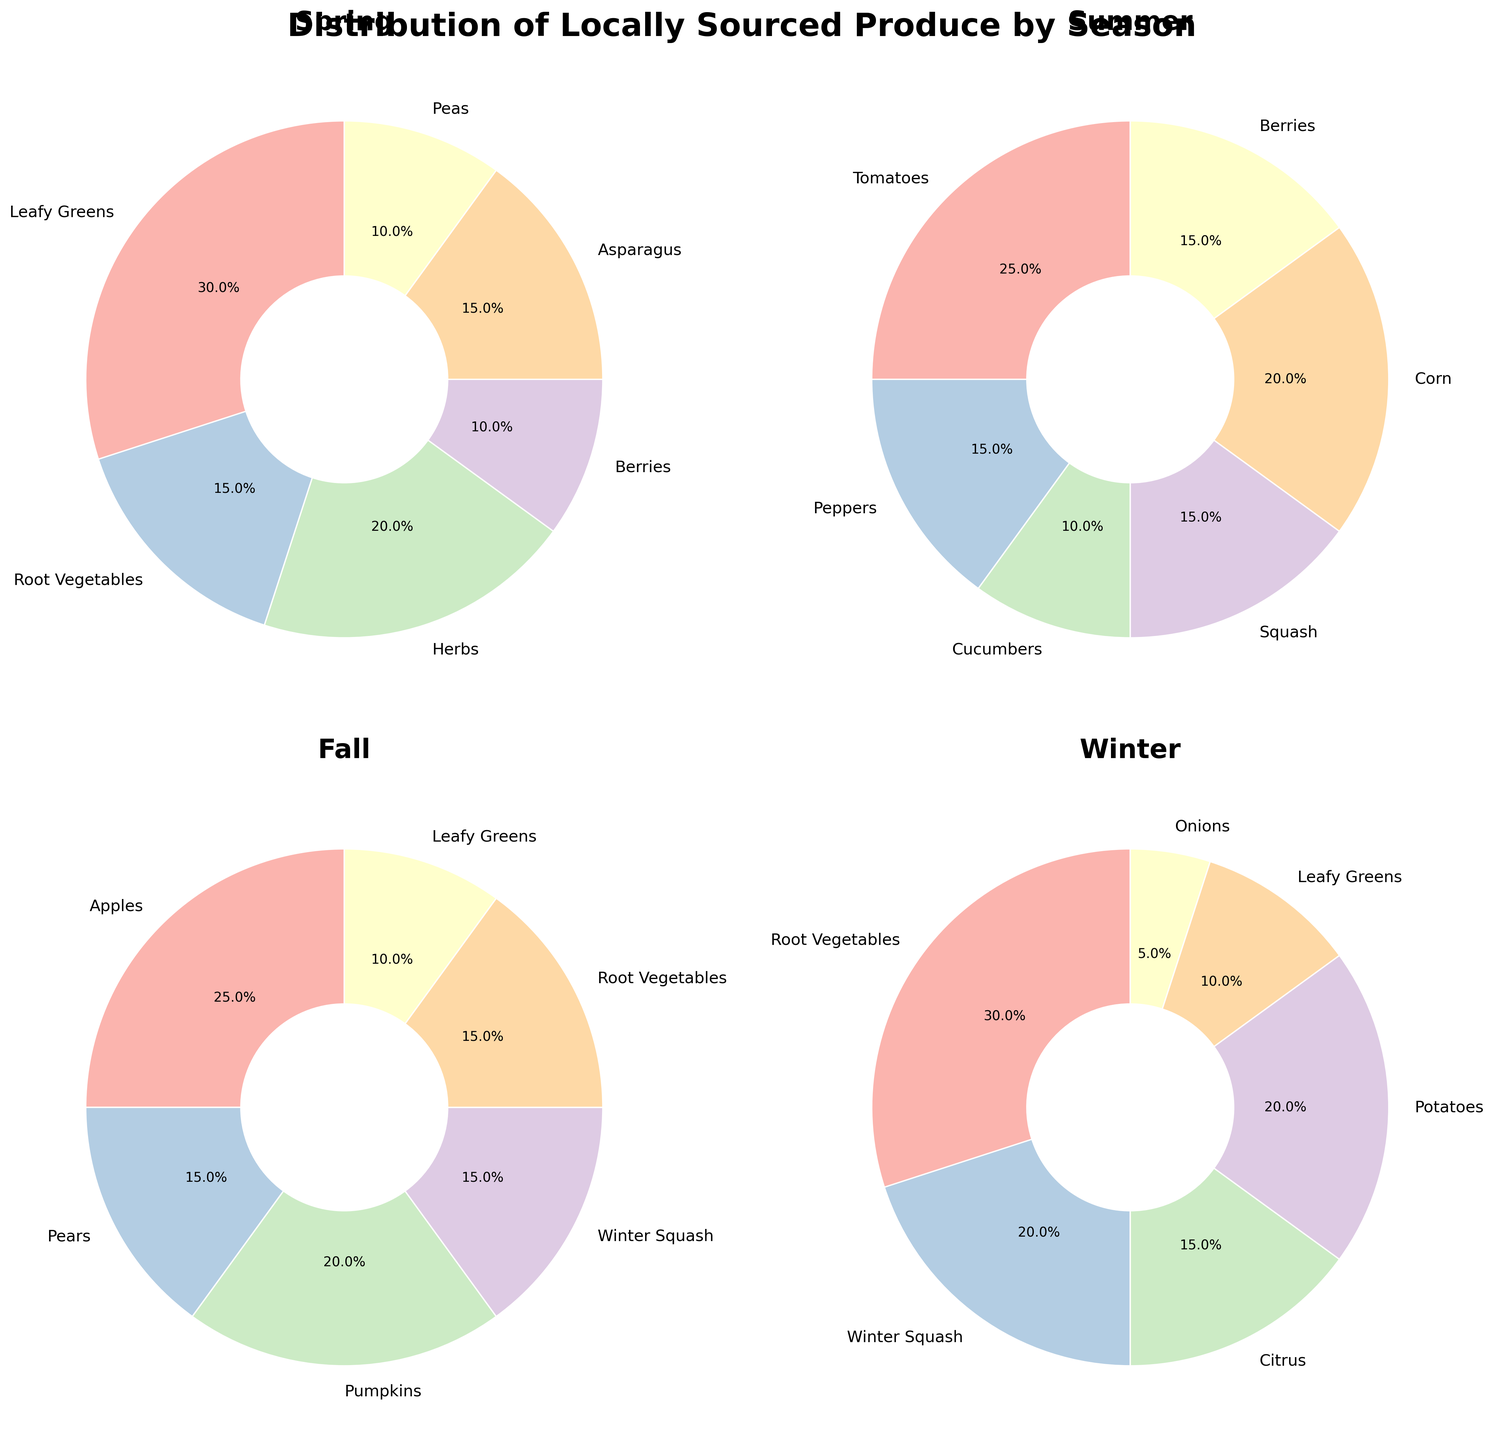What percentage of produce in Winter is composed of Root Vegetables and Potatoes combined? First, locate the percentages of Root Vegetables (30%) and Potatoes (20%) in Winter. Then, add these percentages together: 30% + 20% = 50%.
Answer: 50% Which season has the highest percentage of a single type of produce? By scanning each plot, we find the highest single percentages: Spring - Leafy Greens (30%), Summer - Tomatoes (25%), Fall - Apples (25%), and Winter - Root Vegetables (30%). The highest of these is 30%, found in both Spring and Winter.
Answer: Spring and Winter How do the percentages of Berries compare between Spring and Summer? In Spring, Berries are 10% whereas in Summer, Berries are 15%. By comparing 10% and 15%, we see that Berries have a higher percentage in Summer than in Spring.
Answer: Higher in Summer Which season has the lowest diversity in produce types, assuming diversity is represented by the number of different produce types listed? Count the number of different produce types in each season on the pie charts: Spring (6 types), Summer (6 types), Fall (6 types), Winter (6 types). All seasons show 6 types of produce, indicating equal diversity.
Answer: All seasons What is the combined percentage of Leafy Greens across all seasons? Add the percentages of Leafy Greens from each season: Spring (30%), Fall (10%), Winter (10%). Calculating: 30% + 10% + 10% = 50%.
Answer: 50% Which season has the highest percentage of produce composed entirely of fruits? Identify the fruits and their percentages: Spring (Berries-10%), Summer (Berries-15%, Tomatoes considered fruits - 25%), Fall (Apples-25%, Pears-15%), Winter (Citrus-15%). Summer (15% Berries + 25% Tomatoes = 40%) has the highest total percentage of fruits.
Answer: Summer How does the percentage of Root Vegetables change from Spring to Winter? Root Vegetables in Spring are 15% and in Winter they are 30%. The change is 30% - 15% = 15% increase.
Answer: 15% increase In which seasons do Root Vegetables and Winter Squash both appear, and what are their percentages? Identify the seasons and their percentages: Spring (Root Vegetables 15%, no Winter Squash), Summer (no Root Vegetables or Winter Squash), Fall (Root Vegetables 15%, Winter Squash 15%), Winter (Root Vegetables 30%, Winter Squash 20%). They both appear in Fall and Winter with respective percentages.
Answer: Fall (15%, 15%) and Winter (30%, 20%) How do the percentages of Asparagus in Spring and Winter Squash in Winter compare? Compare the percentages: Asparagus in Spring (15%) and Winter Squash in Winter (20%). Winter Squash in Winter has a higher percentage.
Answer: Winter Squash in Winter has a higher percentage 